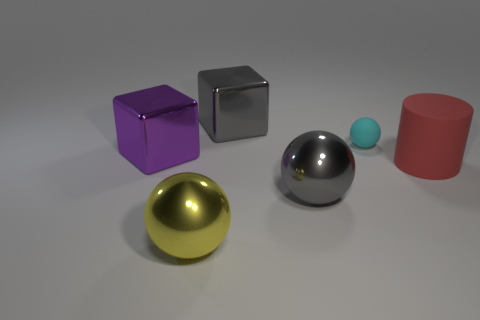Add 1 tiny objects. How many objects exist? 7 Subtract all cubes. How many objects are left? 4 Add 6 cubes. How many cubes are left? 8 Add 2 big green objects. How many big green objects exist? 2 Subtract 0 green blocks. How many objects are left? 6 Subtract all tiny cyan matte balls. Subtract all small matte spheres. How many objects are left? 4 